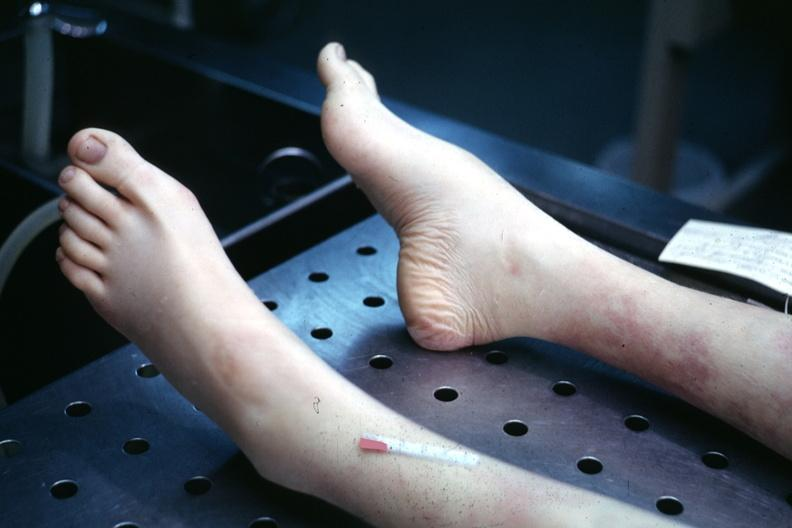s feet present?
Answer the question using a single word or phrase. Yes 